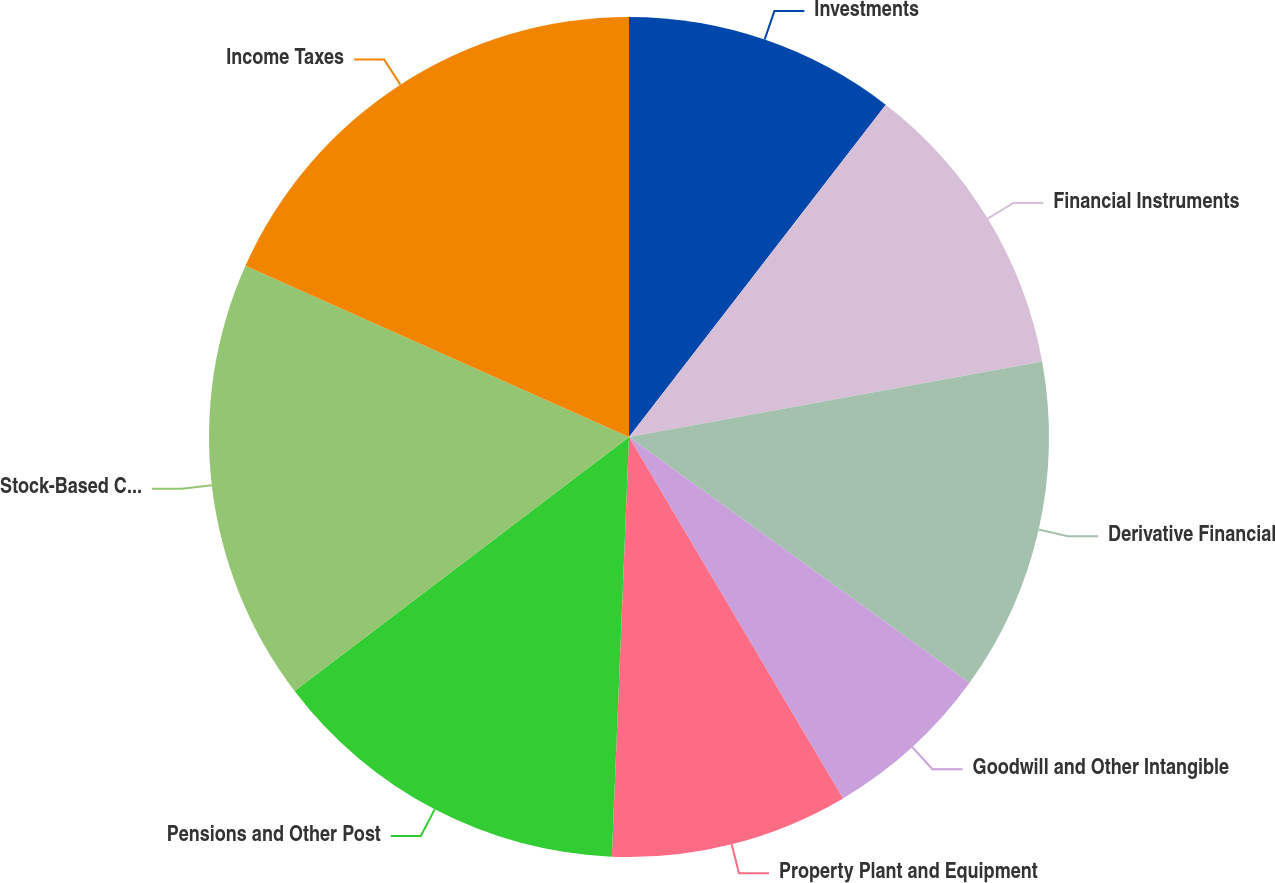Convert chart to OTSL. <chart><loc_0><loc_0><loc_500><loc_500><pie_chart><fcel>Investments<fcel>Financial Instruments<fcel>Derivative Financial<fcel>Goodwill and Other Intangible<fcel>Property Plant and Equipment<fcel>Pensions and Other Post<fcel>Stock-Based Compensation<fcel>Income Taxes<nl><fcel>10.47%<fcel>11.65%<fcel>12.83%<fcel>6.54%<fcel>9.16%<fcel>14.01%<fcel>17.02%<fcel>18.32%<nl></chart> 